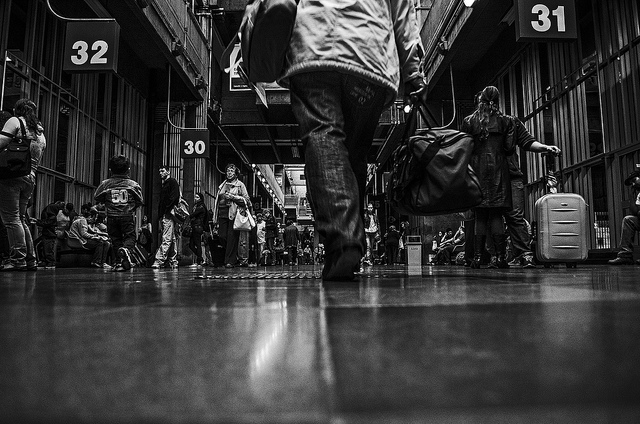Identify the text displayed in this image. 32 31 30 50 